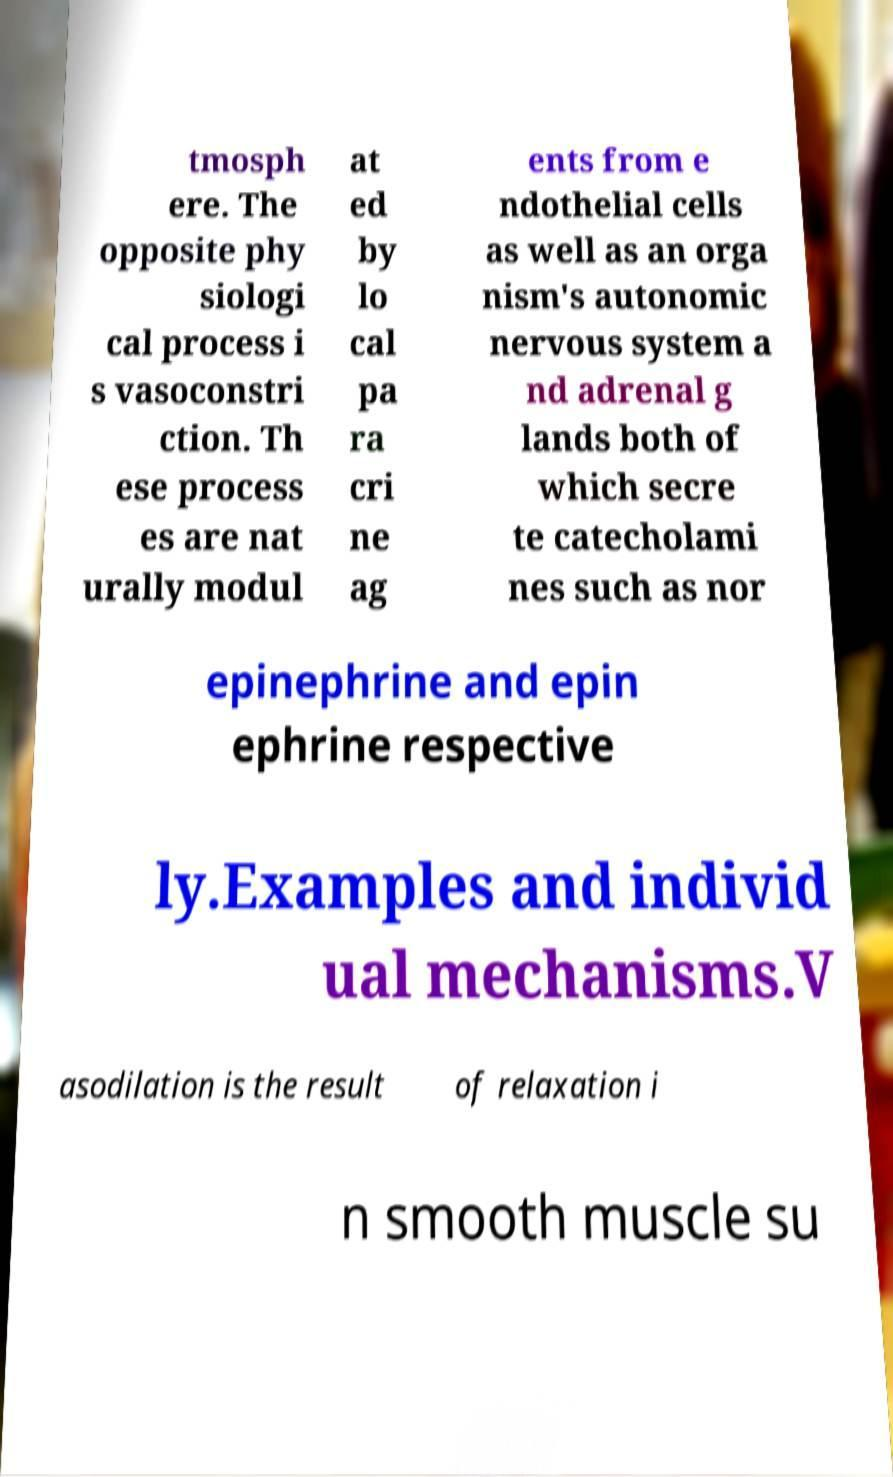Please identify and transcribe the text found in this image. tmosph ere. The opposite phy siologi cal process i s vasoconstri ction. Th ese process es are nat urally modul at ed by lo cal pa ra cri ne ag ents from e ndothelial cells as well as an orga nism's autonomic nervous system a nd adrenal g lands both of which secre te catecholami nes such as nor epinephrine and epin ephrine respective ly.Examples and individ ual mechanisms.V asodilation is the result of relaxation i n smooth muscle su 